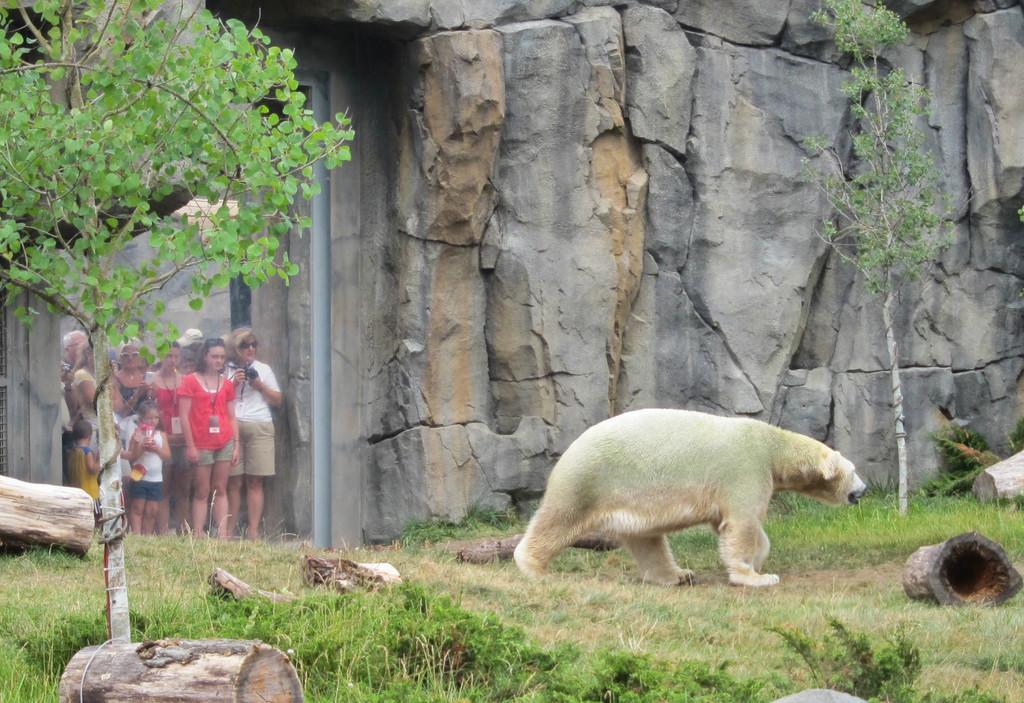Can you describe this image briefly? In the image we can see a bear is walking on the ground and there are trees, logs and grass on the ground. In the background there is a rock wall and few persons are standing at the glass door. 